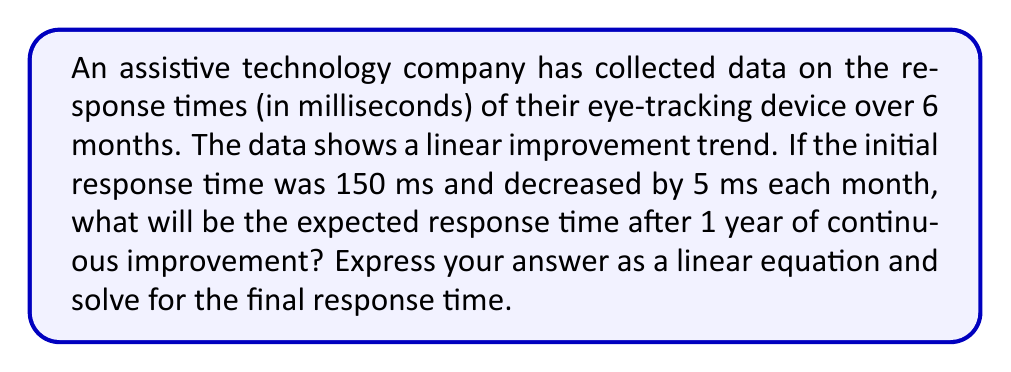Give your solution to this math problem. Let's approach this step-by-step:

1) First, let's define our variables:
   $x$ = number of months
   $y$ = response time in milliseconds

2) We're told that the initial response time was 150 ms, so when $x = 0$, $y = 150$.

3) The response time decreases by 5 ms each month. This gives us the slope of our line: $m = -5$.

4) Using the point-slope form of a linear equation:
   $y - y_1 = m(x - x_1)$
   $y - 150 = -5(x - 0)$

5) Simplify:
   $y - 150 = -5x$
   $y = -5x + 150$

6) This is our linear equation. To find the response time after 1 year, we need to plug in $x = 12$ (as there are 12 months in a year):

   $y = -5(12) + 150$
   $y = -60 + 150$
   $y = 90$

Therefore, after 1 year (12 months), the expected response time will be 90 ms.
Answer: $y = -5x + 150$; 90 ms 